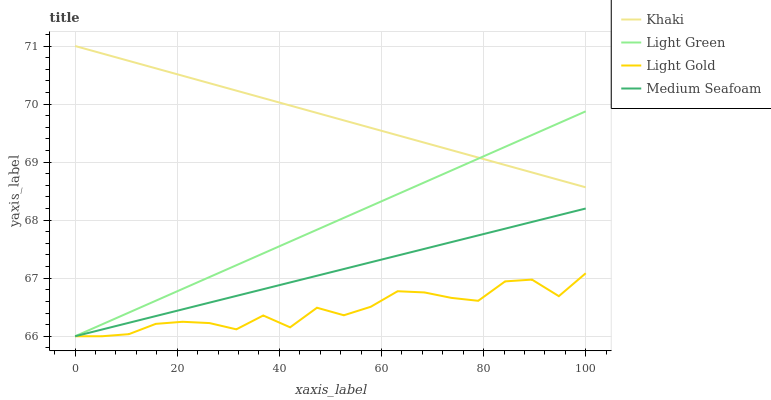Does Light Gold have the minimum area under the curve?
Answer yes or no. Yes. Does Khaki have the maximum area under the curve?
Answer yes or no. Yes. Does Medium Seafoam have the minimum area under the curve?
Answer yes or no. No. Does Medium Seafoam have the maximum area under the curve?
Answer yes or no. No. Is Khaki the smoothest?
Answer yes or no. Yes. Is Light Gold the roughest?
Answer yes or no. Yes. Is Medium Seafoam the smoothest?
Answer yes or no. No. Is Medium Seafoam the roughest?
Answer yes or no. No. Does Light Gold have the lowest value?
Answer yes or no. Yes. Does Khaki have the highest value?
Answer yes or no. Yes. Does Medium Seafoam have the highest value?
Answer yes or no. No. Is Medium Seafoam less than Khaki?
Answer yes or no. Yes. Is Khaki greater than Medium Seafoam?
Answer yes or no. Yes. Does Light Green intersect Medium Seafoam?
Answer yes or no. Yes. Is Light Green less than Medium Seafoam?
Answer yes or no. No. Is Light Green greater than Medium Seafoam?
Answer yes or no. No. Does Medium Seafoam intersect Khaki?
Answer yes or no. No. 